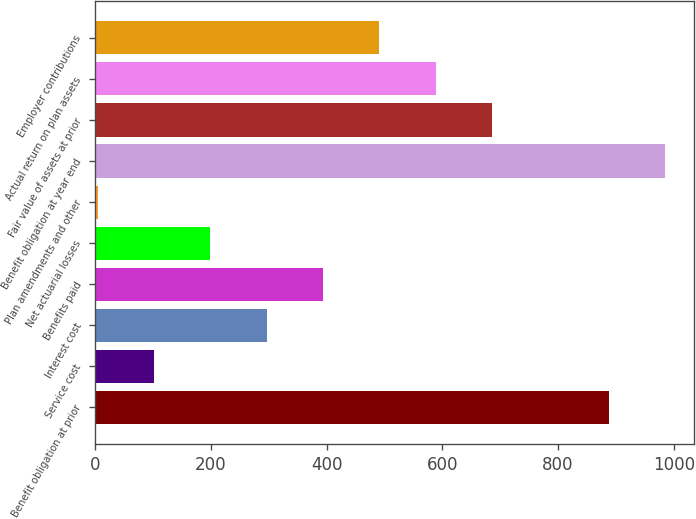<chart> <loc_0><loc_0><loc_500><loc_500><bar_chart><fcel>Benefit obligation at prior<fcel>Service cost<fcel>Interest cost<fcel>Benefits paid<fcel>Net actuarial losses<fcel>Plan amendments and other<fcel>Benefit obligation at year end<fcel>Fair value of assets at prior<fcel>Actual return on plan assets<fcel>Employer contributions<nl><fcel>888.2<fcel>101.46<fcel>296.18<fcel>393.54<fcel>198.82<fcel>4.1<fcel>985.56<fcel>685.62<fcel>588.26<fcel>490.9<nl></chart> 